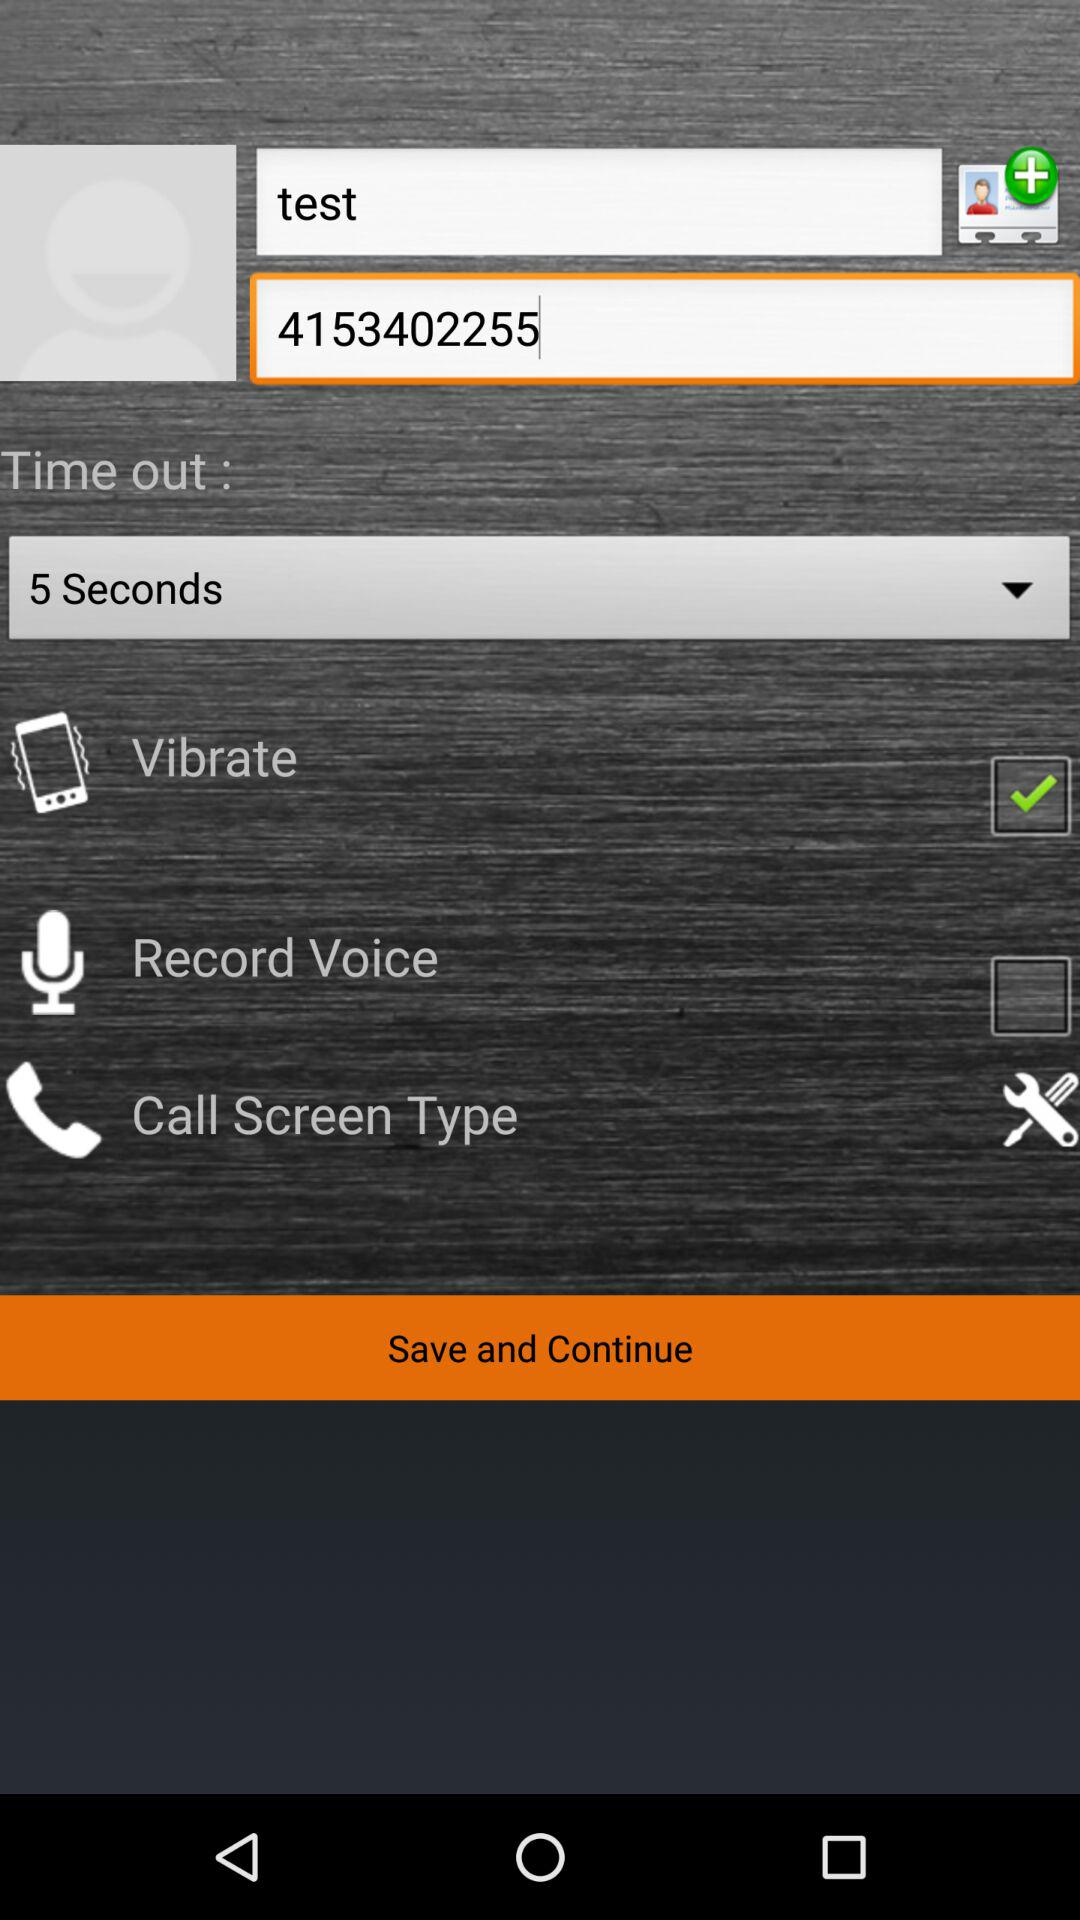What option is selected for time out? The selected option is "5 Seconds". 